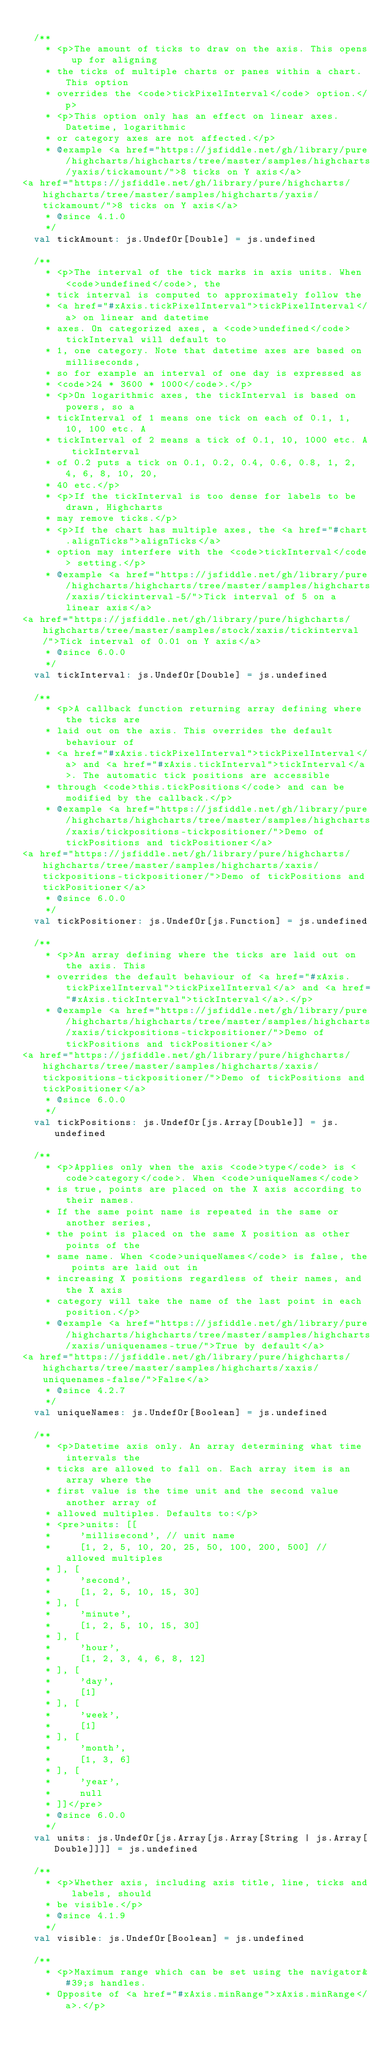Convert code to text. <code><loc_0><loc_0><loc_500><loc_500><_Scala_>
  /**
    * <p>The amount of ticks to draw on the axis. This opens up for aligning
    * the ticks of multiple charts or panes within a chart. This option
    * overrides the <code>tickPixelInterval</code> option.</p>
    * <p>This option only has an effect on linear axes. Datetime, logarithmic
    * or category axes are not affected.</p>
    * @example <a href="https://jsfiddle.net/gh/library/pure/highcharts/highcharts/tree/master/samples/highcharts/yaxis/tickamount/">8 ticks on Y axis</a>
<a href="https://jsfiddle.net/gh/library/pure/highcharts/highcharts/tree/master/samples/highcharts/yaxis/tickamount/">8 ticks on Y axis</a>
    * @since 4.1.0
    */
  val tickAmount: js.UndefOr[Double] = js.undefined

  /**
    * <p>The interval of the tick marks in axis units. When <code>undefined</code>, the
    * tick interval is computed to approximately follow the
    * <a href="#xAxis.tickPixelInterval">tickPixelInterval</a> on linear and datetime
    * axes. On categorized axes, a <code>undefined</code> tickInterval will default to
    * 1, one category. Note that datetime axes are based on milliseconds,
    * so for example an interval of one day is expressed as
    * <code>24 * 3600 * 1000</code>.</p>
    * <p>On logarithmic axes, the tickInterval is based on powers, so a
    * tickInterval of 1 means one tick on each of 0.1, 1, 10, 100 etc. A
    * tickInterval of 2 means a tick of 0.1, 10, 1000 etc. A tickInterval
    * of 0.2 puts a tick on 0.1, 0.2, 0.4, 0.6, 0.8, 1, 2, 4, 6, 8, 10, 20,
    * 40 etc.</p>
    * <p>If the tickInterval is too dense for labels to be drawn, Highcharts
    * may remove ticks.</p>
    * <p>If the chart has multiple axes, the <a href="#chart.alignTicks">alignTicks</a>
    * option may interfere with the <code>tickInterval</code> setting.</p>
    * @example <a href="https://jsfiddle.net/gh/library/pure/highcharts/highcharts/tree/master/samples/highcharts/xaxis/tickinterval-5/">Tick interval of 5 on a linear axis</a>
<a href="https://jsfiddle.net/gh/library/pure/highcharts/highcharts/tree/master/samples/stock/xaxis/tickinterval/">Tick interval of 0.01 on Y axis</a>
    * @since 6.0.0
    */
  val tickInterval: js.UndefOr[Double] = js.undefined

  /**
    * <p>A callback function returning array defining where the ticks are
    * laid out on the axis. This overrides the default behaviour of
    * <a href="#xAxis.tickPixelInterval">tickPixelInterval</a> and <a href="#xAxis.tickInterval">tickInterval</a>. The automatic tick positions are accessible
    * through <code>this.tickPositions</code> and can be modified by the callback.</p>
    * @example <a href="https://jsfiddle.net/gh/library/pure/highcharts/highcharts/tree/master/samples/highcharts/xaxis/tickpositions-tickpositioner/">Demo of tickPositions and tickPositioner</a>
<a href="https://jsfiddle.net/gh/library/pure/highcharts/highcharts/tree/master/samples/highcharts/xaxis/tickpositions-tickpositioner/">Demo of tickPositions and tickPositioner</a>
    * @since 6.0.0
    */
  val tickPositioner: js.UndefOr[js.Function] = js.undefined

  /**
    * <p>An array defining where the ticks are laid out on the axis. This
    * overrides the default behaviour of <a href="#xAxis.tickPixelInterval">tickPixelInterval</a> and <a href="#xAxis.tickInterval">tickInterval</a>.</p>
    * @example <a href="https://jsfiddle.net/gh/library/pure/highcharts/highcharts/tree/master/samples/highcharts/xaxis/tickpositions-tickpositioner/">Demo of tickPositions and tickPositioner</a>
<a href="https://jsfiddle.net/gh/library/pure/highcharts/highcharts/tree/master/samples/highcharts/xaxis/tickpositions-tickpositioner/">Demo of tickPositions and tickPositioner</a>
    * @since 6.0.0
    */
  val tickPositions: js.UndefOr[js.Array[Double]] = js.undefined

  /**
    * <p>Applies only when the axis <code>type</code> is <code>category</code>. When <code>uniqueNames</code>
    * is true, points are placed on the X axis according to their names.
    * If the same point name is repeated in the same or another series,
    * the point is placed on the same X position as other points of the
    * same name. When <code>uniqueNames</code> is false, the points are laid out in
    * increasing X positions regardless of their names, and the X axis
    * category will take the name of the last point in each position.</p>
    * @example <a href="https://jsfiddle.net/gh/library/pure/highcharts/highcharts/tree/master/samples/highcharts/xaxis/uniquenames-true/">True by default</a>
<a href="https://jsfiddle.net/gh/library/pure/highcharts/highcharts/tree/master/samples/highcharts/xaxis/uniquenames-false/">False</a>
    * @since 4.2.7
    */
  val uniqueNames: js.UndefOr[Boolean] = js.undefined

  /**
    * <p>Datetime axis only. An array determining what time intervals the
    * ticks are allowed to fall on. Each array item is an array where the
    * first value is the time unit and the second value another array of
    * allowed multiples. Defaults to:</p>
    * <pre>units: [[
    *     'millisecond', // unit name
    *     [1, 2, 5, 10, 20, 25, 50, 100, 200, 500] // allowed multiples
    * ], [
    *     'second',
    *     [1, 2, 5, 10, 15, 30]
    * ], [
    *     'minute',
    *     [1, 2, 5, 10, 15, 30]
    * ], [
    *     'hour',
    *     [1, 2, 3, 4, 6, 8, 12]
    * ], [
    *     'day',
    *     [1]
    * ], [
    *     'week',
    *     [1]
    * ], [
    *     'month',
    *     [1, 3, 6]
    * ], [
    *     'year',
    *     null
    * ]]</pre>
    * @since 6.0.0
    */
  val units: js.UndefOr[js.Array[js.Array[String | js.Array[Double]]]] = js.undefined

  /**
    * <p>Whether axis, including axis title, line, ticks and labels, should
    * be visible.</p>
    * @since 4.1.9
    */
  val visible: js.UndefOr[Boolean] = js.undefined

  /**
    * <p>Maximum range which can be set using the navigator&#39;s handles.
    * Opposite of <a href="#xAxis.minRange">xAxis.minRange</a>.</p></code> 